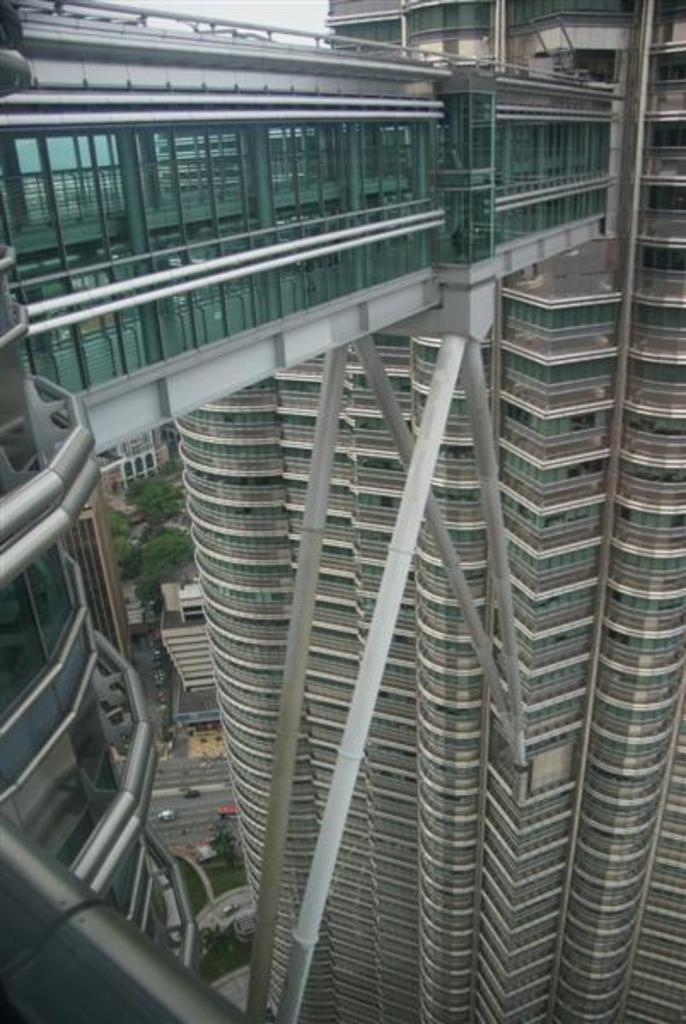What type of structures can be seen in the image? There are buildings in the image. Is there any connection between the buildings and other objects? Yes, there is a bridge attached to a building in the image. What can be found on the road in the image? There are vehicles parked on the road in the image. What type of natural elements are present in the image? There are trees in the image. Can you tell me how many creatures are swimming in the river in the image? There is no river or creatures present in the image; it features buildings, a bridge, vehicles, and trees. 